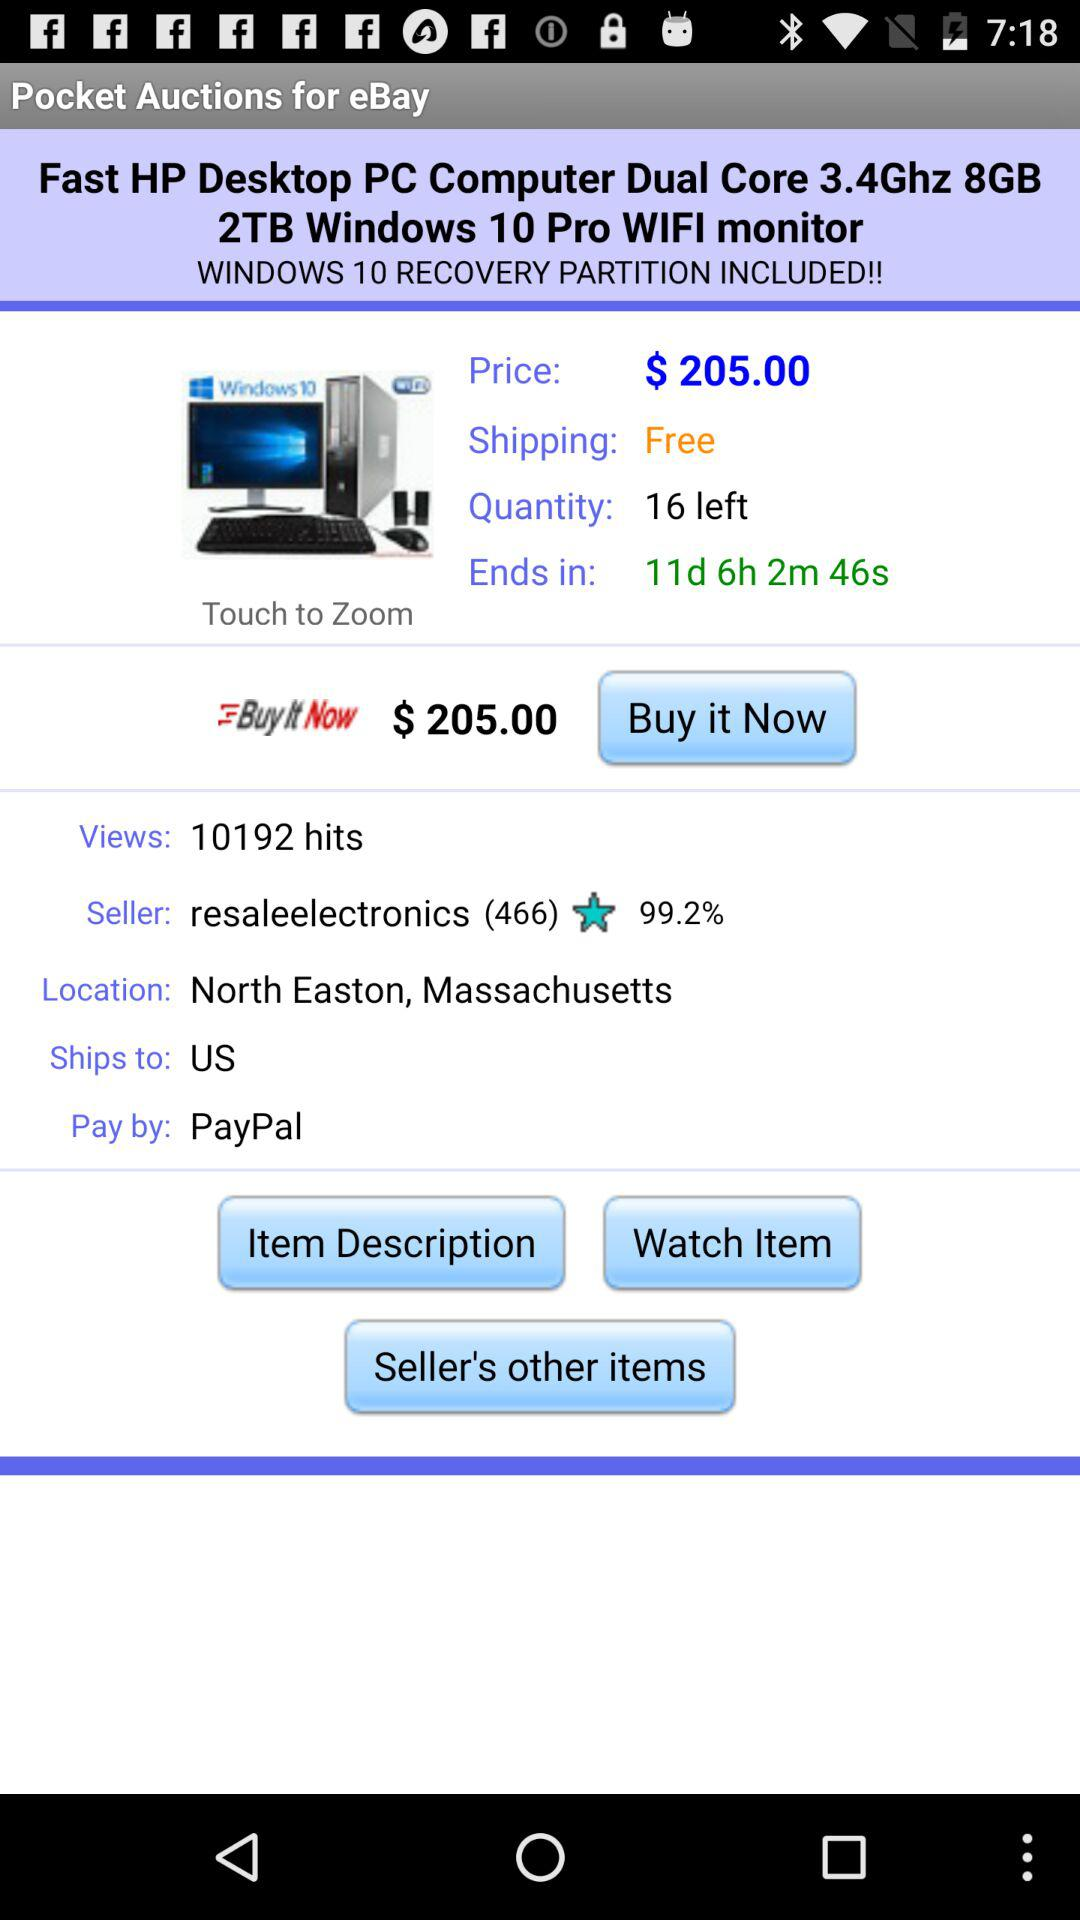What is the left quantity? The left quantity is 16. 